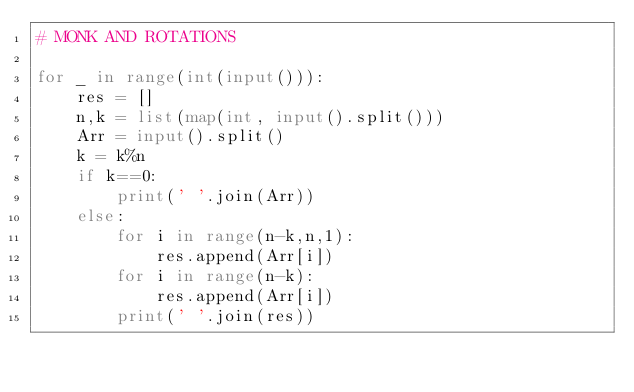Convert code to text. <code><loc_0><loc_0><loc_500><loc_500><_Python_># MONK AND ROTATIONS

for _ in range(int(input())):
    res = []
    n,k = list(map(int, input().split()))
    Arr = input().split()
    k = k%n
    if k==0:
        print(' '.join(Arr))
    else:
        for i in range(n-k,n,1):
            res.append(Arr[i])
        for i in range(n-k):
            res.append(Arr[i])
        print(' '.join(res))

</code> 